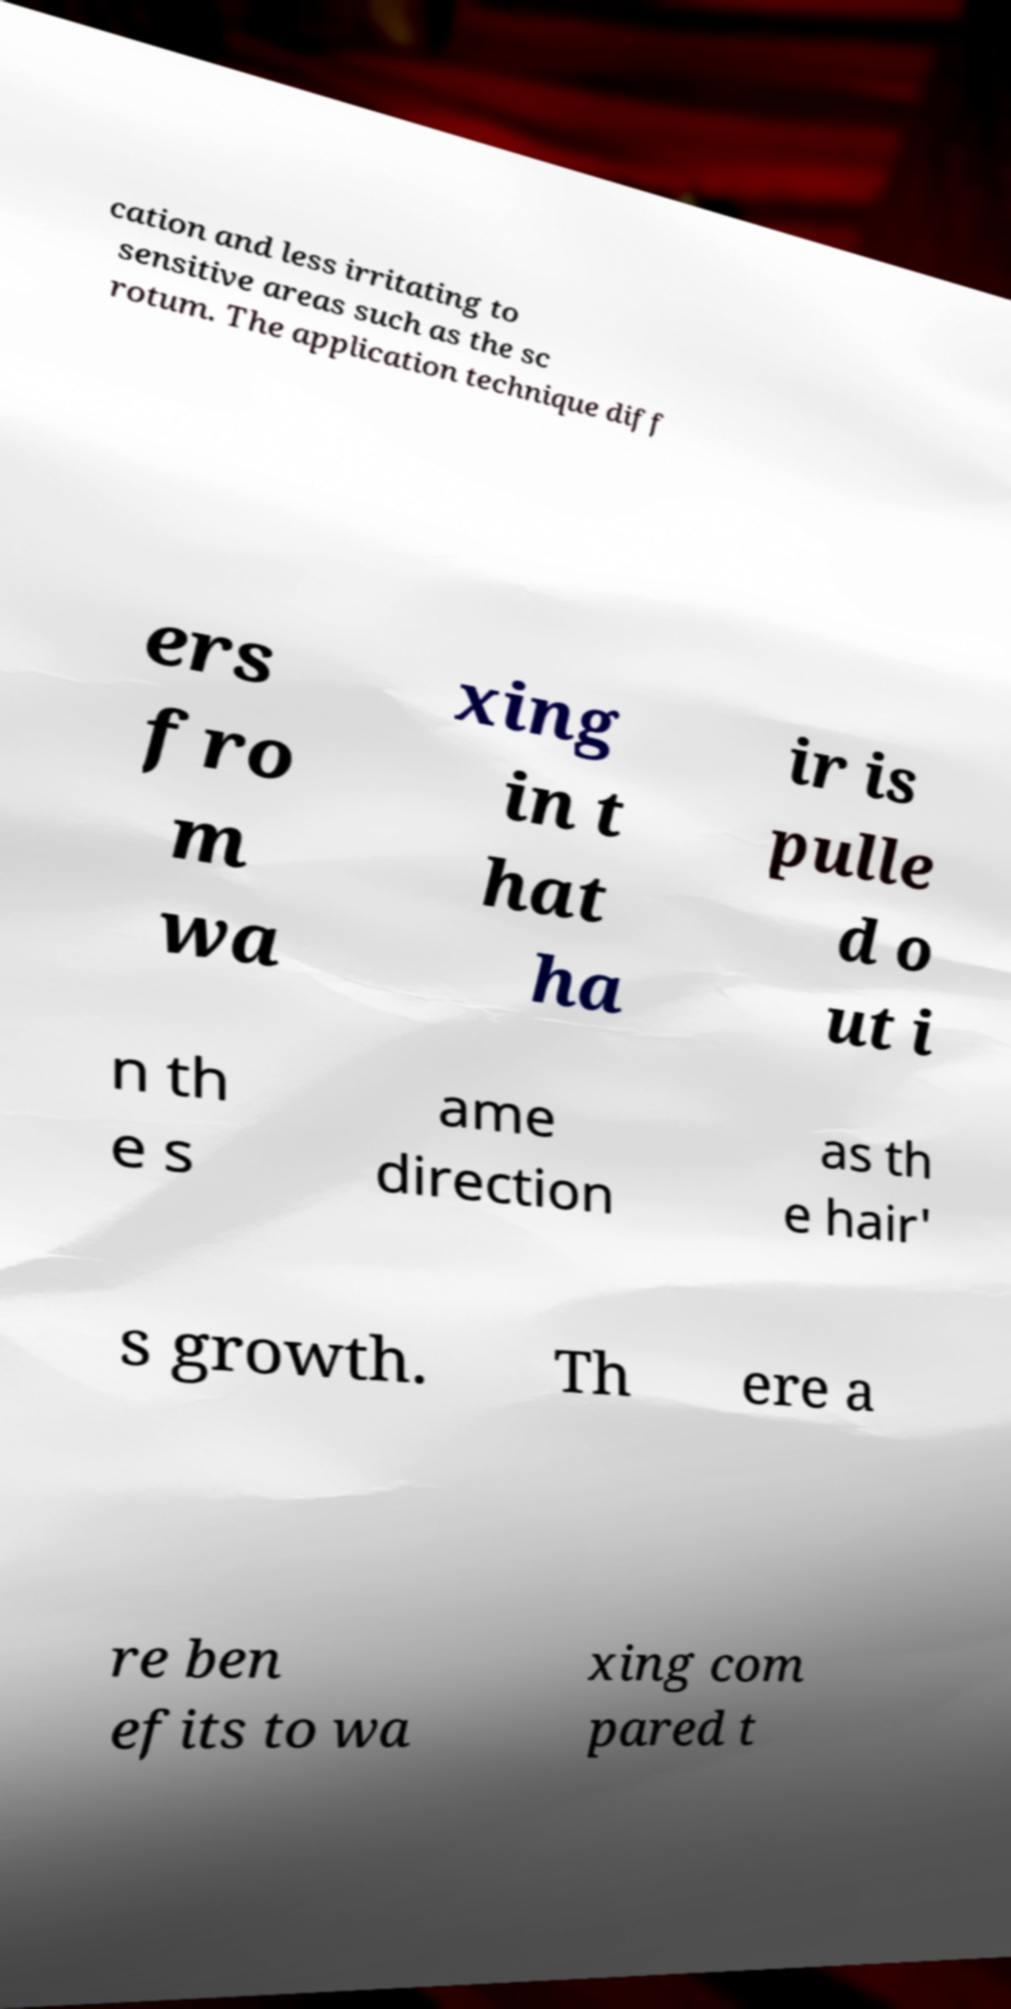Please read and relay the text visible in this image. What does it say? cation and less irritating to sensitive areas such as the sc rotum. The application technique diff ers fro m wa xing in t hat ha ir is pulle d o ut i n th e s ame direction as th e hair' s growth. Th ere a re ben efits to wa xing com pared t 